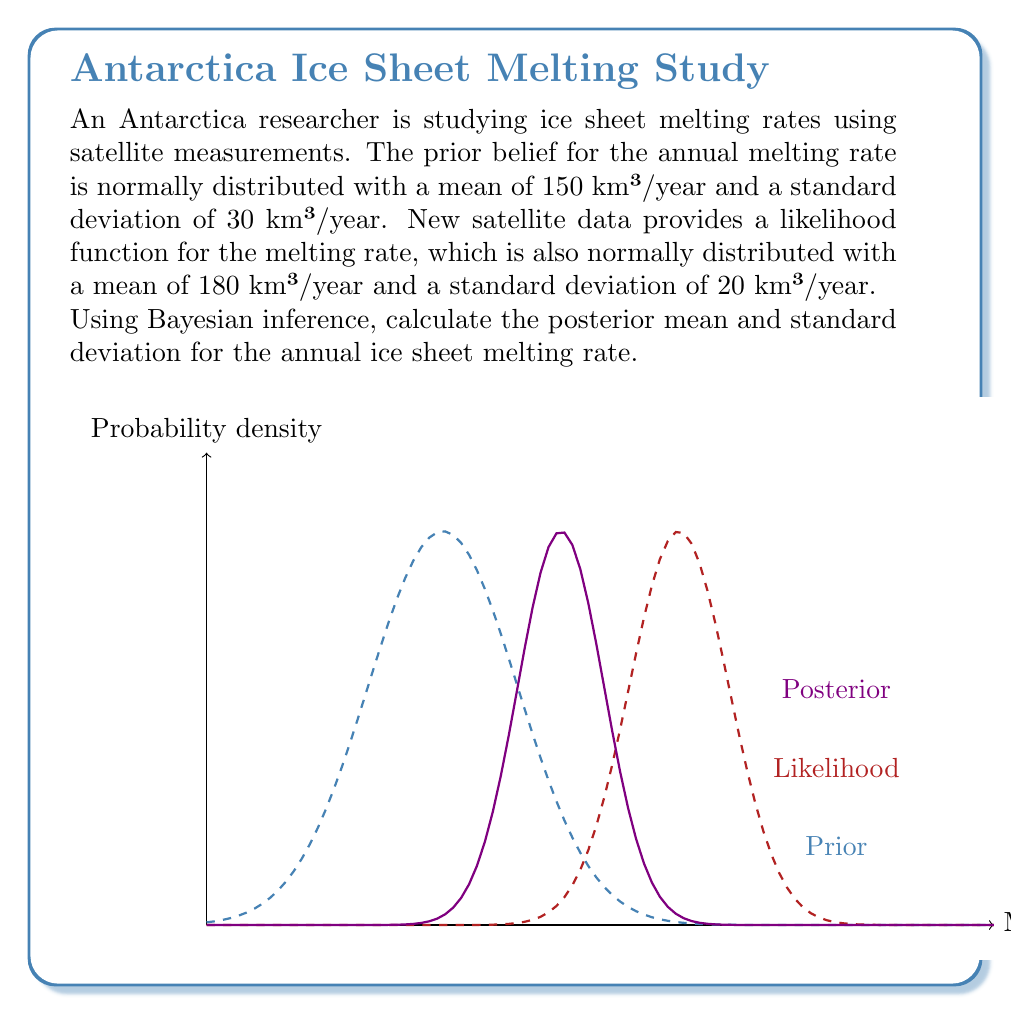Help me with this question. To solve this problem using Bayesian inference, we'll use the formula for combining two normal distributions:

1) Let's define our variables:
   $\mu_0 = 150$ (prior mean)
   $\sigma_0 = 30$ (prior standard deviation)
   $\mu_1 = 180$ (likelihood mean)
   $\sigma_1 = 20$ (likelihood standard deviation)

2) The posterior mean $\mu_p$ is given by:

   $$\mu_p = \frac{\frac{\mu_0}{\sigma_0^2} + \frac{\mu_1}{\sigma_1^2}}{\frac{1}{\sigma_0^2} + \frac{1}{\sigma_1^2}}$$

3) Substituting the values:

   $$\mu_p = \frac{\frac{150}{30^2} + \frac{180}{20^2}}{\frac{1}{30^2} + \frac{1}{20^2}} = \frac{0.167 + 0.45}{0.00111 + 0.0025} = \frac{0.617}{0.00361} \approx 170.91$$

4) The posterior variance $\sigma_p^2$ is given by:

   $$\sigma_p^2 = \frac{1}{\frac{1}{\sigma_0^2} + \frac{1}{\sigma_1^2}}$$

5) Substituting the values:

   $$\sigma_p^2 = \frac{1}{\frac{1}{30^2} + \frac{1}{20^2}} = \frac{1}{0.00111 + 0.0025} = \frac{1}{0.00361} \approx 276.93$$

6) Taking the square root to get the standard deviation:

   $$\sigma_p = \sqrt{276.93} \approx 16.64$$

Thus, the posterior distribution for the annual ice sheet melting rate is normally distributed with a mean of approximately 170.91 km³/year and a standard deviation of approximately 16.64 km³/year.
Answer: Posterior mean ≈ 170.91 km³/year, posterior standard deviation ≈ 16.64 km³/year 